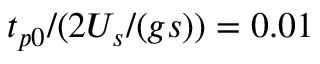<formula> <loc_0><loc_0><loc_500><loc_500>t _ { p 0 } / ( 2 U _ { s } / ( g s ) ) = 0 . 0 1</formula> 